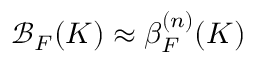<formula> <loc_0><loc_0><loc_500><loc_500>\mathcal { B } _ { F } ( K ) \approx \beta _ { F } ^ { ( n ) } ( K )</formula> 